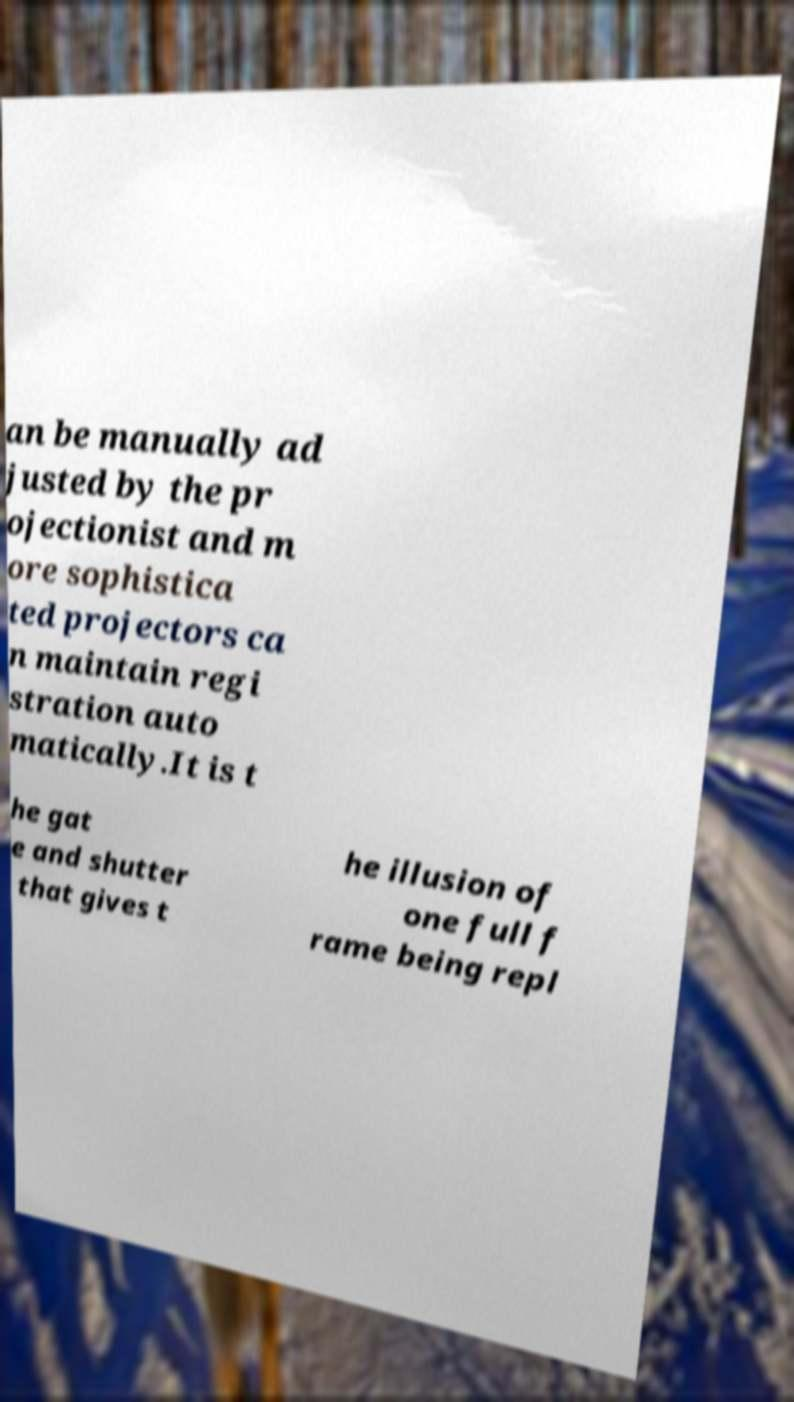For documentation purposes, I need the text within this image transcribed. Could you provide that? an be manually ad justed by the pr ojectionist and m ore sophistica ted projectors ca n maintain regi stration auto matically.It is t he gat e and shutter that gives t he illusion of one full f rame being repl 